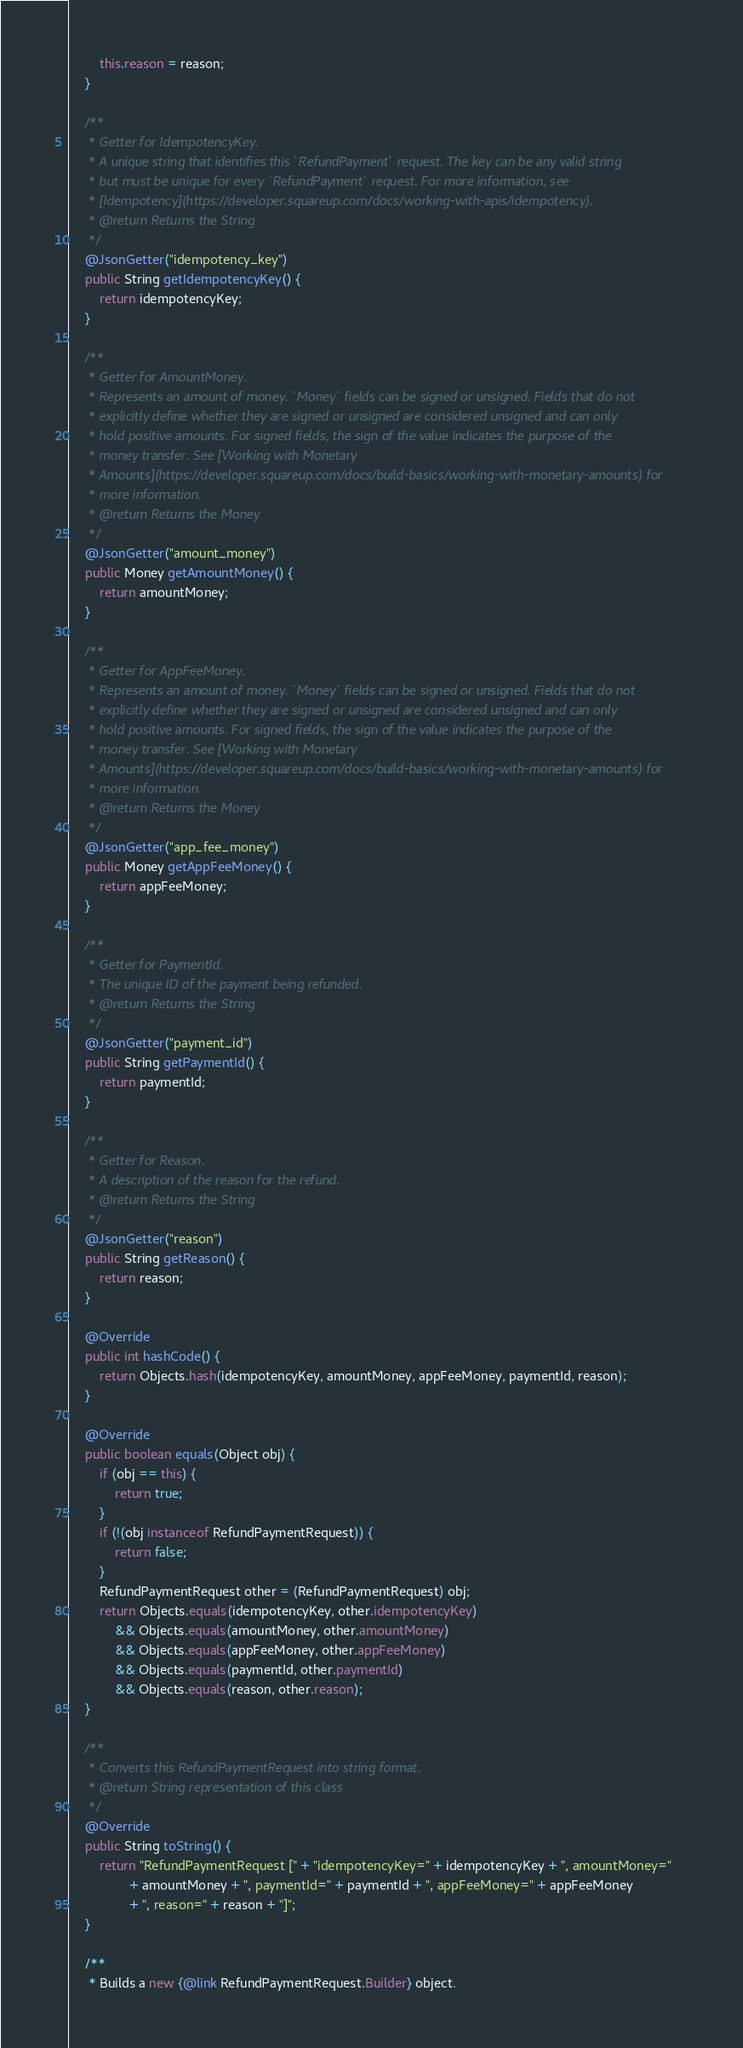Convert code to text. <code><loc_0><loc_0><loc_500><loc_500><_Java_>        this.reason = reason;
    }

    /**
     * Getter for IdempotencyKey.
     * A unique string that identifies this `RefundPayment` request. The key can be any valid string
     * but must be unique for every `RefundPayment` request. For more information, see
     * [Idempotency](https://developer.squareup.com/docs/working-with-apis/idempotency).
     * @return Returns the String
     */
    @JsonGetter("idempotency_key")
    public String getIdempotencyKey() {
        return idempotencyKey;
    }

    /**
     * Getter for AmountMoney.
     * Represents an amount of money. `Money` fields can be signed or unsigned. Fields that do not
     * explicitly define whether they are signed or unsigned are considered unsigned and can only
     * hold positive amounts. For signed fields, the sign of the value indicates the purpose of the
     * money transfer. See [Working with Monetary
     * Amounts](https://developer.squareup.com/docs/build-basics/working-with-monetary-amounts) for
     * more information.
     * @return Returns the Money
     */
    @JsonGetter("amount_money")
    public Money getAmountMoney() {
        return amountMoney;
    }

    /**
     * Getter for AppFeeMoney.
     * Represents an amount of money. `Money` fields can be signed or unsigned. Fields that do not
     * explicitly define whether they are signed or unsigned are considered unsigned and can only
     * hold positive amounts. For signed fields, the sign of the value indicates the purpose of the
     * money transfer. See [Working with Monetary
     * Amounts](https://developer.squareup.com/docs/build-basics/working-with-monetary-amounts) for
     * more information.
     * @return Returns the Money
     */
    @JsonGetter("app_fee_money")
    public Money getAppFeeMoney() {
        return appFeeMoney;
    }

    /**
     * Getter for PaymentId.
     * The unique ID of the payment being refunded.
     * @return Returns the String
     */
    @JsonGetter("payment_id")
    public String getPaymentId() {
        return paymentId;
    }

    /**
     * Getter for Reason.
     * A description of the reason for the refund.
     * @return Returns the String
     */
    @JsonGetter("reason")
    public String getReason() {
        return reason;
    }

    @Override
    public int hashCode() {
        return Objects.hash(idempotencyKey, amountMoney, appFeeMoney, paymentId, reason);
    }

    @Override
    public boolean equals(Object obj) {
        if (obj == this) {
            return true;
        }
        if (!(obj instanceof RefundPaymentRequest)) {
            return false;
        }
        RefundPaymentRequest other = (RefundPaymentRequest) obj;
        return Objects.equals(idempotencyKey, other.idempotencyKey)
            && Objects.equals(amountMoney, other.amountMoney)
            && Objects.equals(appFeeMoney, other.appFeeMoney)
            && Objects.equals(paymentId, other.paymentId)
            && Objects.equals(reason, other.reason);
    }

    /**
     * Converts this RefundPaymentRequest into string format.
     * @return String representation of this class
     */
    @Override
    public String toString() {
        return "RefundPaymentRequest [" + "idempotencyKey=" + idempotencyKey + ", amountMoney="
                + amountMoney + ", paymentId=" + paymentId + ", appFeeMoney=" + appFeeMoney
                + ", reason=" + reason + "]";
    }

    /**
     * Builds a new {@link RefundPaymentRequest.Builder} object.</code> 